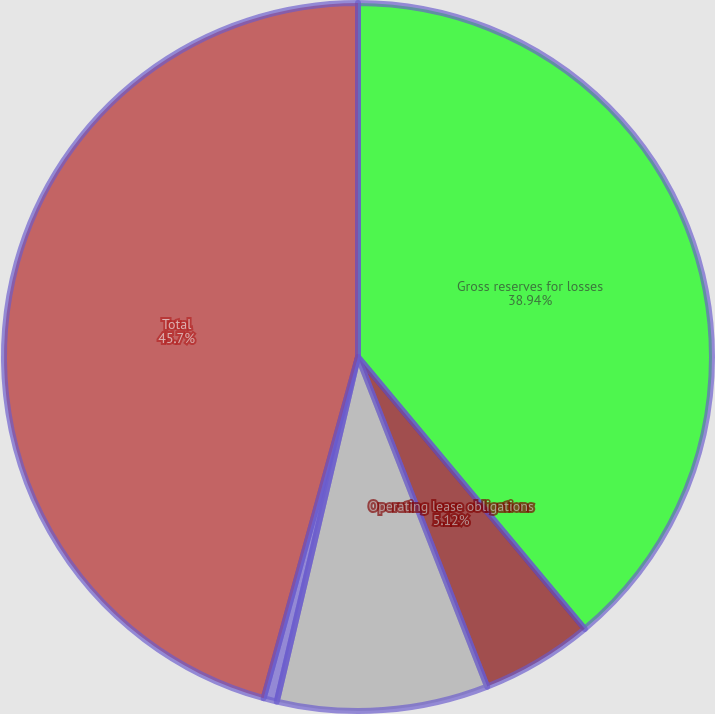<chart> <loc_0><loc_0><loc_500><loc_500><pie_chart><fcel>Gross reserves for losses<fcel>Operating lease obligations<fcel>Interest payments<fcel>Other long-term liabilities<fcel>Total<nl><fcel>38.94%<fcel>5.12%<fcel>9.63%<fcel>0.61%<fcel>45.71%<nl></chart> 